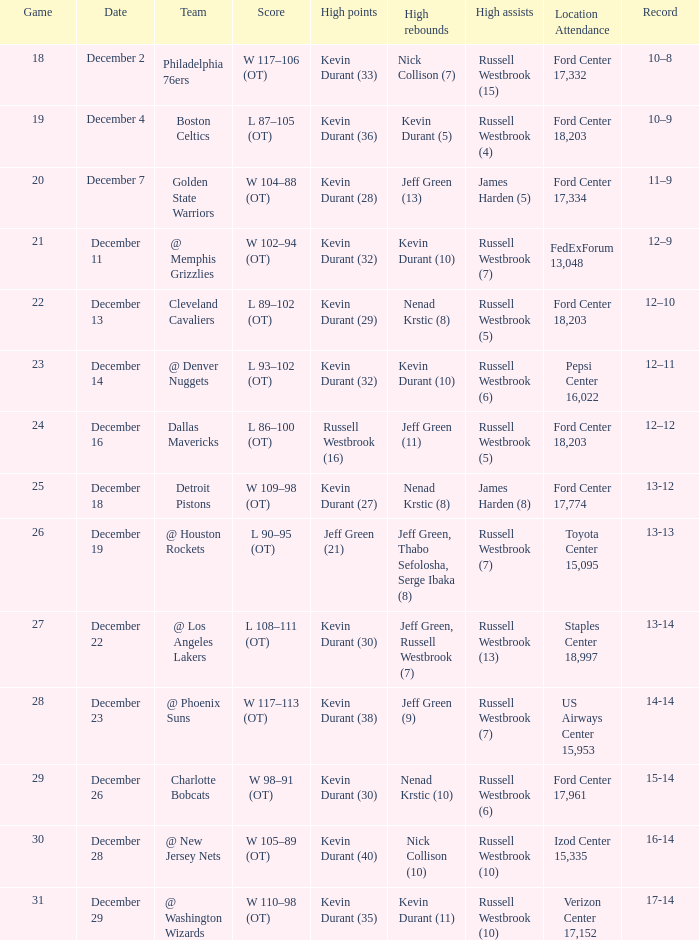What is the score for the date of December 7? W 104–88 (OT). 